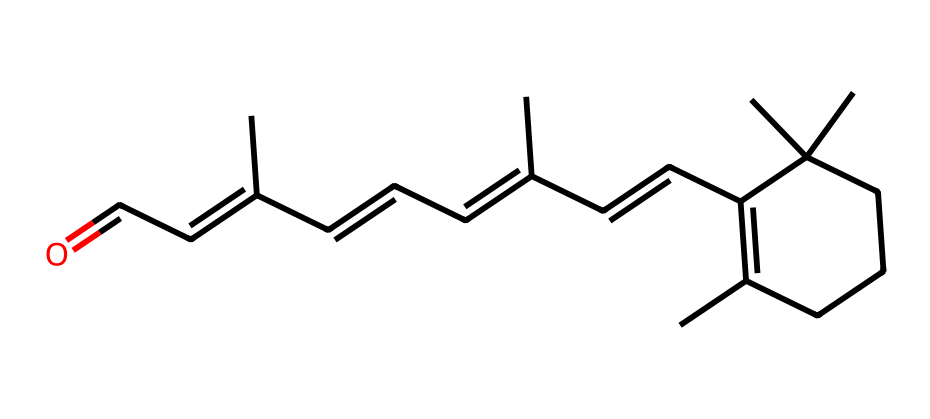What is the molecular formula of retinal? By analyzing the SMILES representation, we can identify the individual atoms and count them. The structure suggests that it contains multiple carbon (C), hydrogen (H), and one oxygen (O) atom. The molecular formula derived from the structure is C20H28O.
Answer: C20H28O How many double bonds are present in this structure? Starting from the SMILES, we can identify the number of double bonds by counting the occurrences of '=' between the carbon atoms. There are a total of 5 double bonds in the structure, confirmed by visualizing the connections in the molecule.
Answer: 5 What type of functional group is present in retinal? The presence of a carbonyl group (C=O), which can be seen in the structure, identifies retinal as containing an aldehyde functional group. The carbon atom at the terminal end of the SMILES indicates this characteristic.
Answer: aldehyde Which feature of retinal allows it to be light-sensitive? The conjugated double bonds chain in retinal allows it to absorb light efficiently. The alternating single and double bonds create a system of π-electrons that can get excited by light, making it photoreactive.
Answer: conjugated double bonds What is the role of retinal in vision? Retinal is a chromophore that undergoes isomerization upon absorbing photons, leading to a conformational change that initiates the visual signal transduction pathway.
Answer: phototransduction 